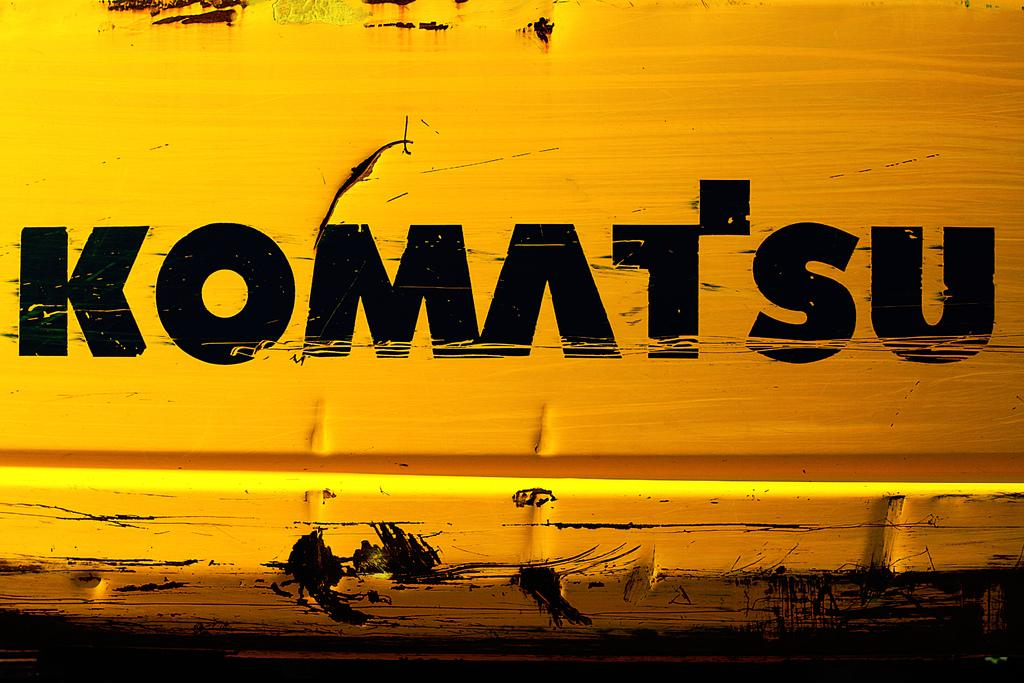<image>
Describe the image concisely. White surface with the word "Komatsu" in black words. 